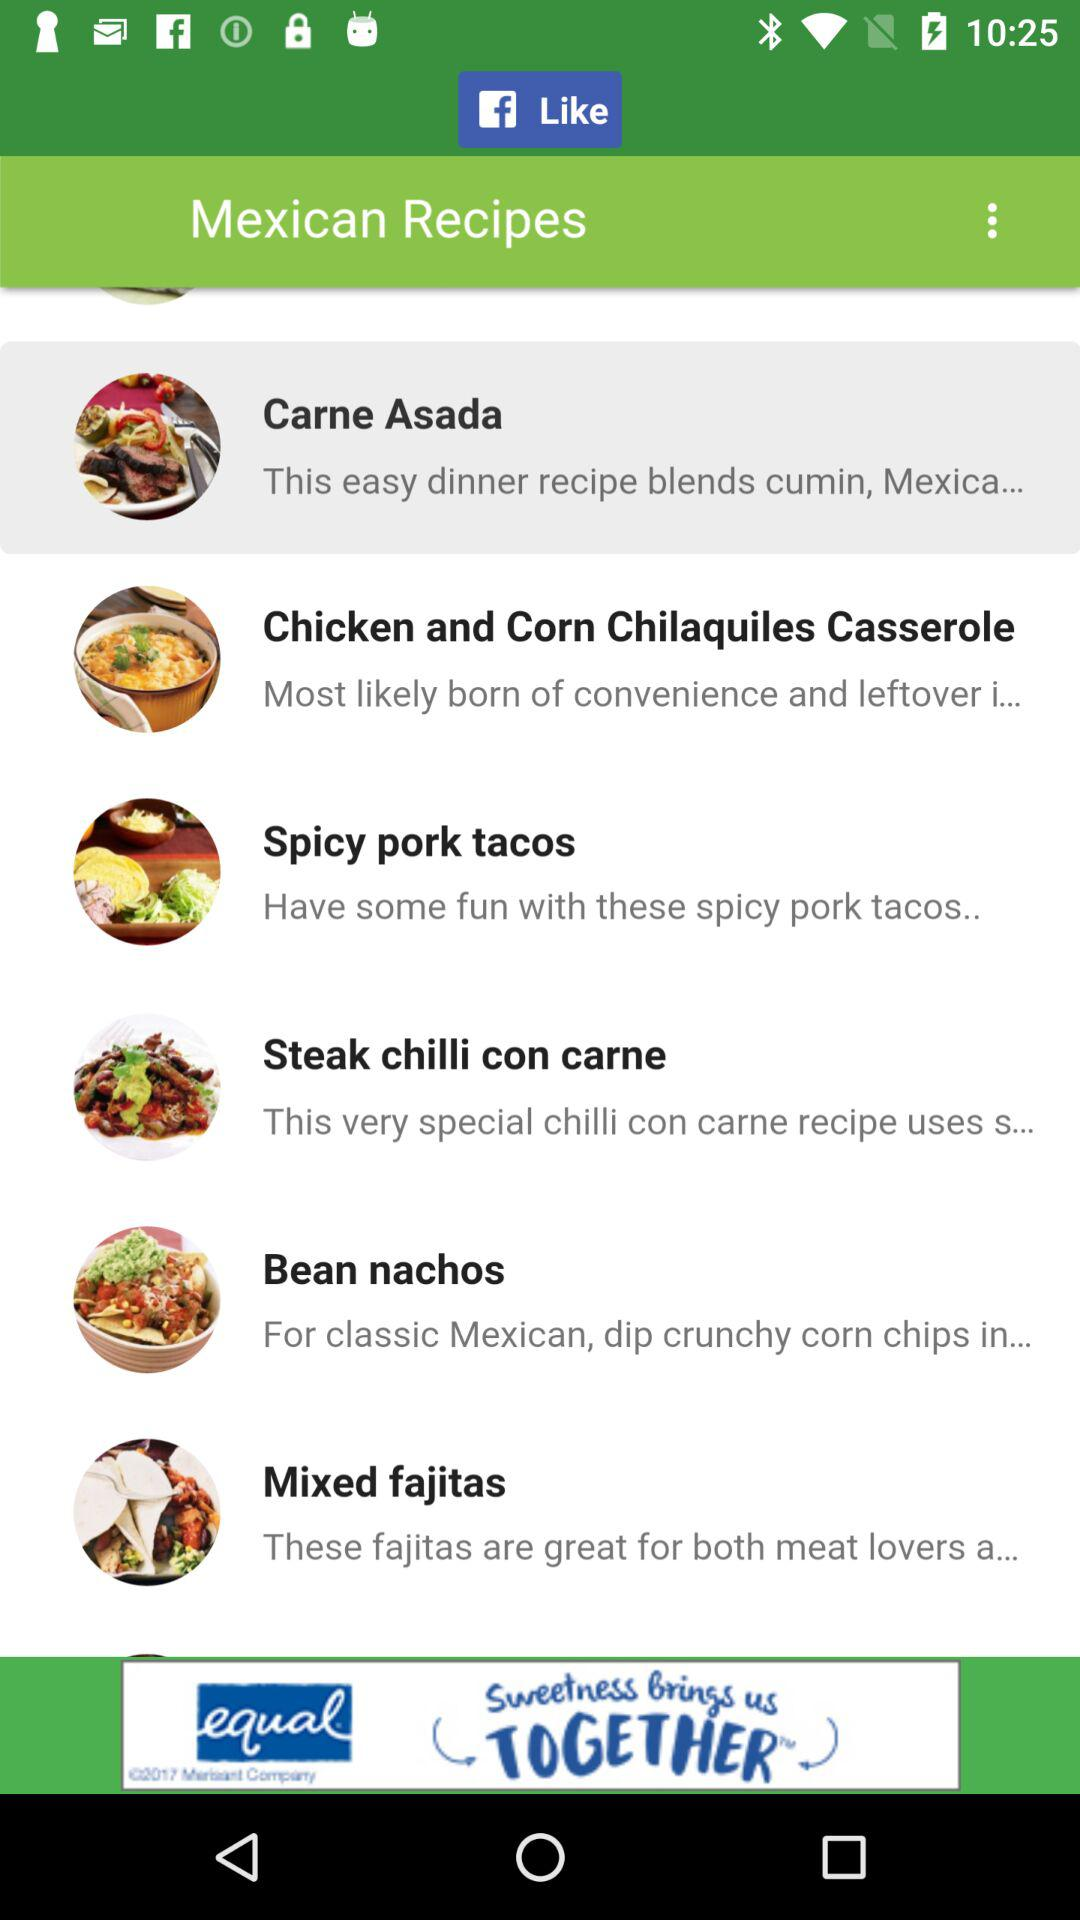How many recipes are there in total?
Answer the question using a single word or phrase. 6 